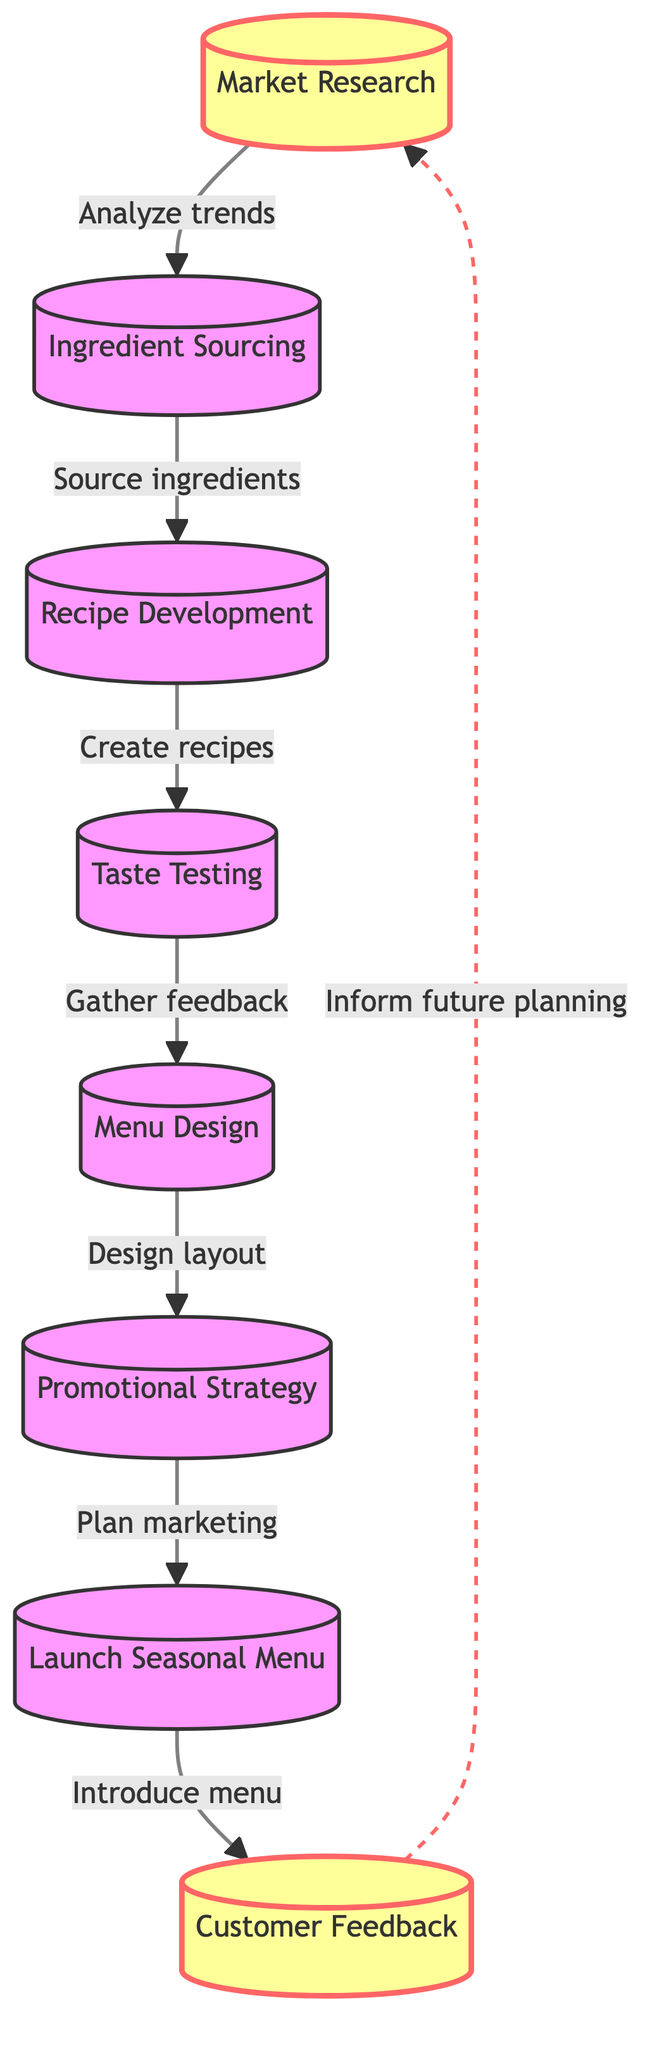What is the first step in the seasonal menu planning process? The first step in the flow chart is "Market Research," which is depicted at the top of the diagram. It indicates the starting point of the seasonal menu planning process.
Answer: Market Research How many total steps are there in the seasonal menu planning process? By counting each element in the flow chart, there are a total of eight steps in the process, ranging from Market Research to Customer Feedback.
Answer: 8 What step comes after Ingredient Sourcing? The flow chart shows that after Ingredient Sourcing, the next step is Recipe Development, illustrating the direct progression in the planning process.
Answer: Recipe Development Which step involves gathering feedback? Taste Testing is the step that includes gathering feedback from staff and customers on the new dishes, as indicated in the diagram.
Answer: Taste Testing What type of feedback informs future planning? The diagram indicates that Customer Feedback is the type of feedback collected, which is used to inform future menu planning decisions.
Answer: Customer Feedback What is the last step before the seasonal menu is launched? The last step before launching the seasonal menu is the Promotional Strategy, which involves planning marketing activities to promote the new menu items.
Answer: Promotional Strategy What flows directly from Taste Testing to another process? From Taste Testing, the flow moves directly to Menu Design, showing that feedback received from taste tests influences how the menu is visually arranged.
Answer: Menu Design What is the relationship between Customer Feedback and Market Research in the diagram? The diagram shows that Customer Feedback feeds back into Market Research, creating a loop where feedback informs future understanding of trends and preferences.
Answer: Inform future planning 